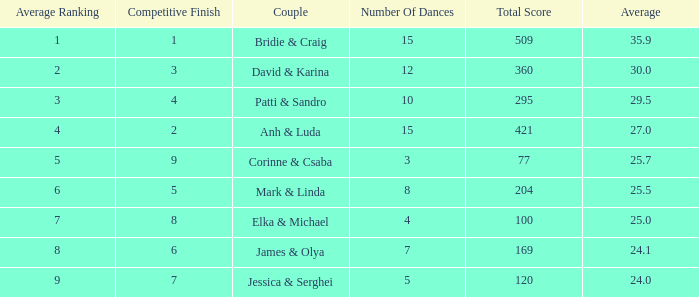What is the total score when 7 is the average ranking? 100.0. 